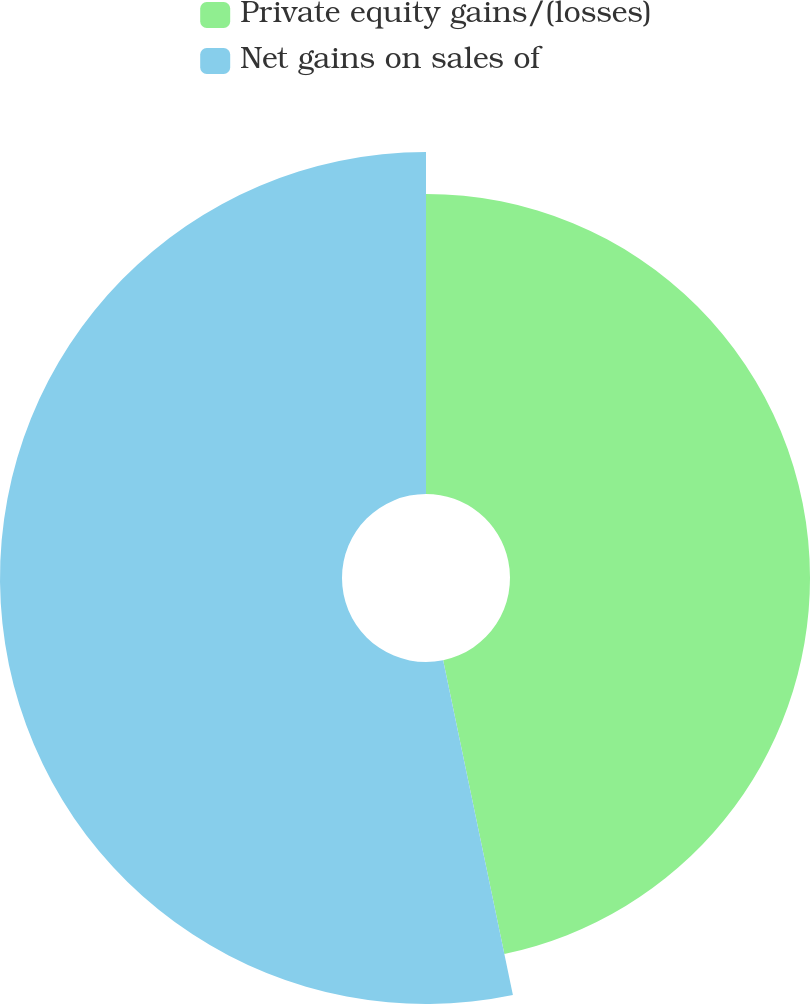<chart> <loc_0><loc_0><loc_500><loc_500><pie_chart><fcel>Private equity gains/(losses)<fcel>Net gains on sales of<nl><fcel>46.73%<fcel>53.27%<nl></chart> 